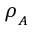<formula> <loc_0><loc_0><loc_500><loc_500>\rho _ { _ { A } }</formula> 